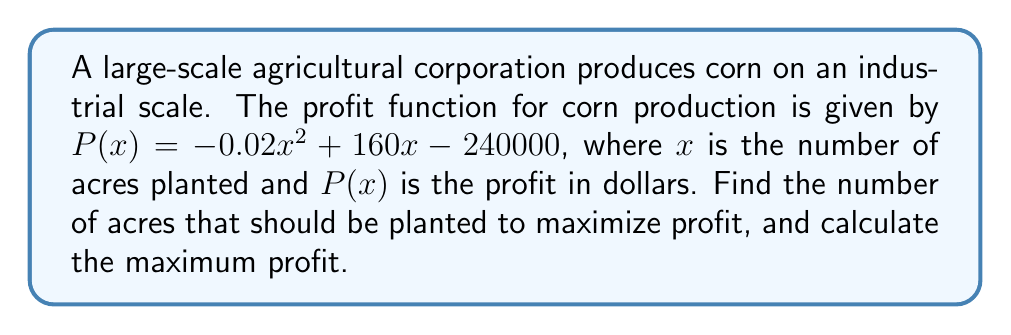Can you solve this math problem? To find the maximum profit point, we need to follow these steps:

1. Find the derivative of the profit function:
   $P'(x) = -0.04x + 160$

2. Set the derivative equal to zero to find the critical point:
   $-0.04x + 160 = 0$
   $-0.04x = -160$
   $x = 4000$

3. Verify that this critical point is a maximum by checking the second derivative:
   $P''(x) = -0.04$
   Since $P''(x)$ is negative, the critical point is a maximum.

4. Calculate the maximum profit by plugging $x = 4000$ into the original profit function:
   $P(4000) = -0.02(4000)^2 + 160(4000) - 240000$
   $= -320000 + 640000 - 240000$
   $= 80000$

Therefore, the corporation should plant 4000 acres of corn to maximize profit, and the maximum profit will be $80,000.
Answer: 4000 acres; $80,000 